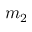Convert formula to latex. <formula><loc_0><loc_0><loc_500><loc_500>m _ { 2 }</formula> 